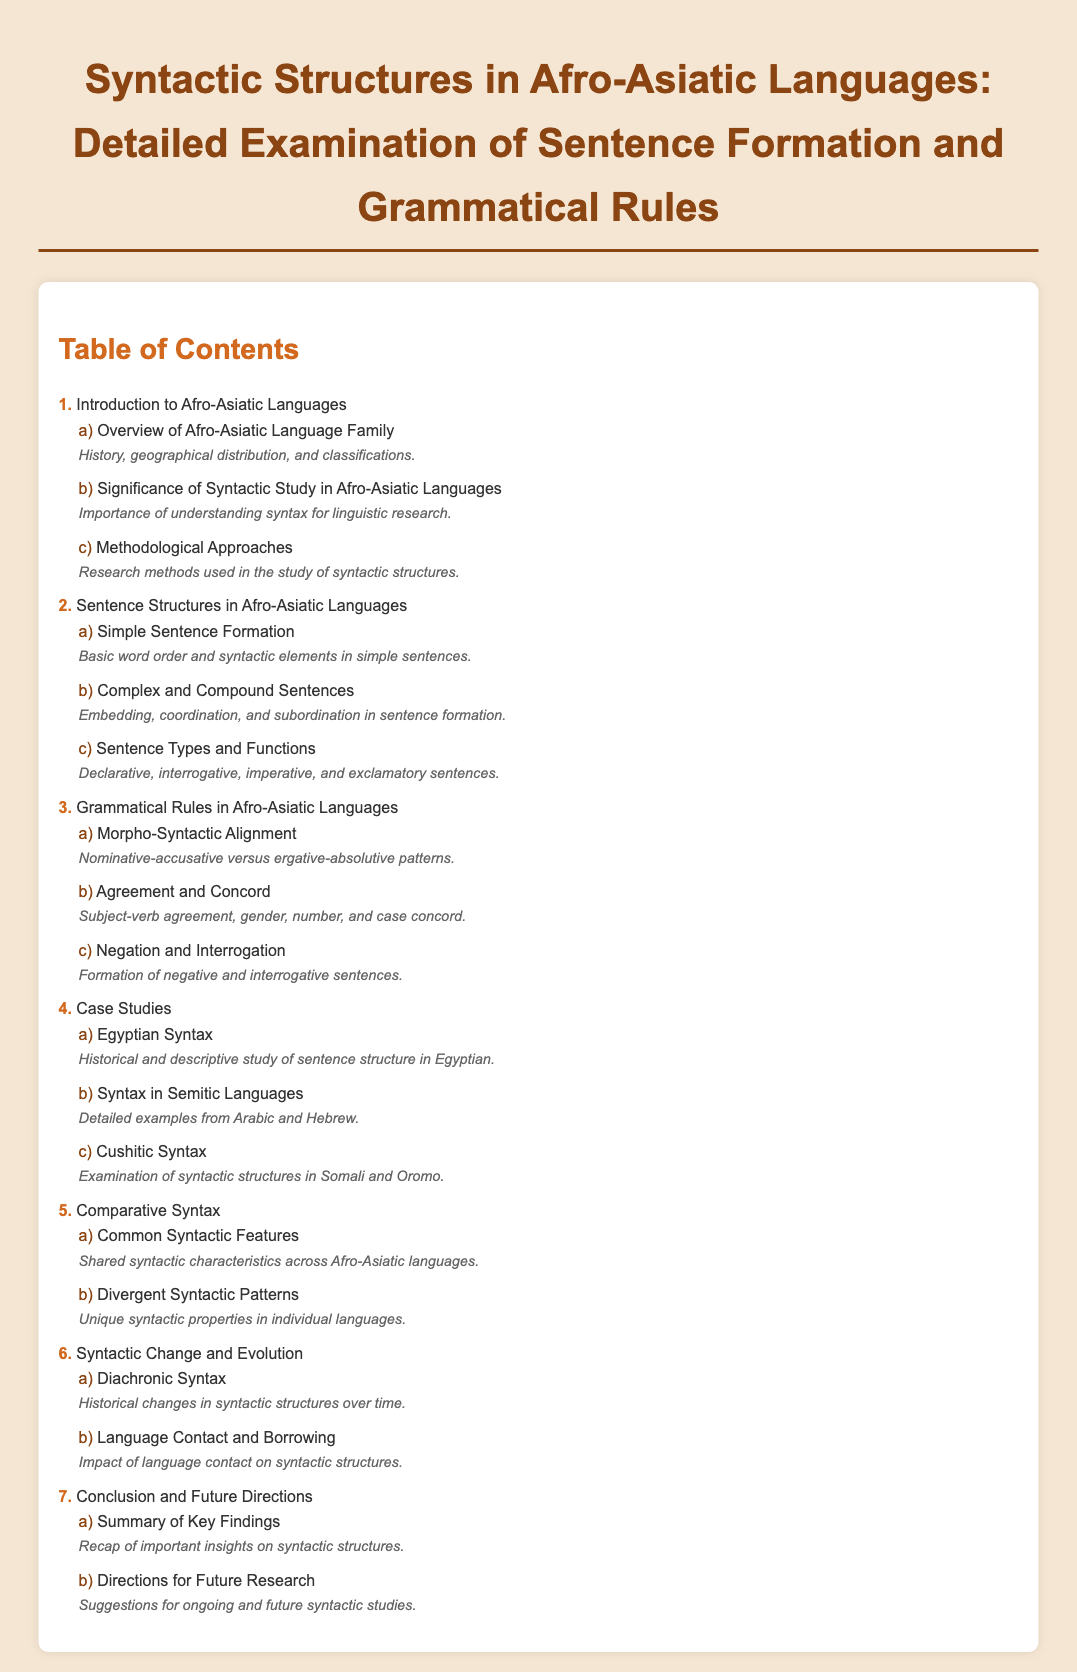What is the title of the document? The title is the main heading of the document, which summarizes its content and focus area.
Answer: Syntactic Structures in Afro-Asiatic Languages: Detailed Examination of Sentence Formation and Grammatical Rules How many main sections are in the Table of Contents? The main sections refer to the top-level items listed in the Table of Contents. Counting them gives us the total number of sections.
Answer: 8 What is the subtitle for the section on "Complex and Compound Sentences"? The subtitle provides additional detail about what this section will cover, indicating the specific focus.
Answer: Embedding, coordination, and subordination in sentence formation Which section examines "Historical changes in syntactic structures over time"? This identifies the specific section of the document that addresses the historical aspect of syntax.
Answer: Diachronic Syntax What is one of the suggestions for ongoing studies mentioned in the document? This asks for information about future research directions indicated in the conclusion section of the document.
Answer: Directions for Future Research Which languages are specifically mentioned in the case study for syntax? This question gathers information about the languages highlighted in the case studies of the document.
Answer: Somali and Oromo What are the "Common Syntactic Features" in Afro-Asiatic languages? This asks for a brief summary of a specific aspect discussed, focusing on shared characteristics across these languages.
Answer: Shared syntactic characteristics across Afro-Asiatic languages 